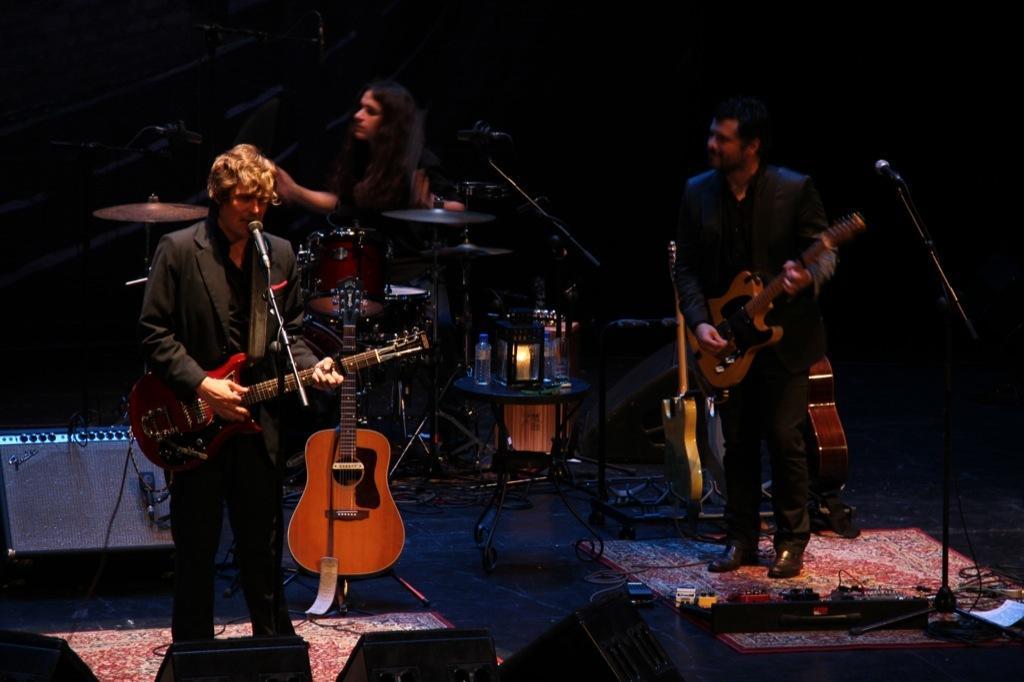How would you summarize this image in a sentence or two? In this image there are two persons standing and holding a guitar. At the middle of the image a person is playing some musical instruments. There is a table having some bottles and lantern on it. At the bottom right there is a plug board. At the left side there is an electrical device. 